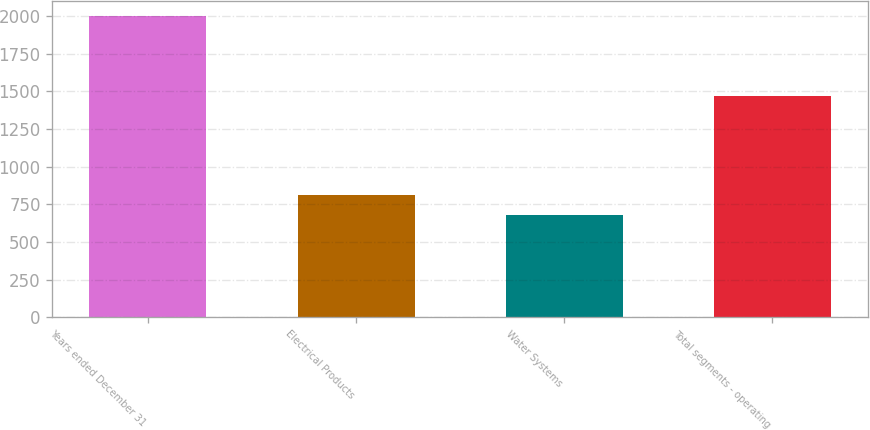<chart> <loc_0><loc_0><loc_500><loc_500><bar_chart><fcel>Years ended December 31<fcel>Electrical Products<fcel>Water Systems<fcel>Total segments - operating<nl><fcel>2002<fcel>811.03<fcel>678.7<fcel>1469.1<nl></chart> 